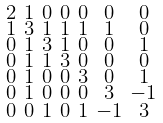<formula> <loc_0><loc_0><loc_500><loc_500>\begin{smallmatrix} 2 & 1 & 0 & 0 & 0 & 0 & 0 \\ 1 & 3 & 1 & 1 & 1 & 1 & 0 \\ 0 & 1 & 3 & 1 & 0 & 0 & 1 \\ 0 & 1 & 1 & 3 & 0 & 0 & 0 \\ 0 & 1 & 0 & 0 & 3 & 0 & 1 \\ 0 & 1 & 0 & 0 & 0 & 3 & - 1 \\ 0 & 0 & 1 & 0 & 1 & - 1 & 3 \end{smallmatrix}</formula> 